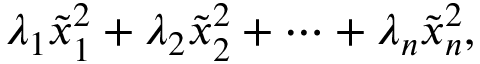Convert formula to latex. <formula><loc_0><loc_0><loc_500><loc_500>\lambda _ { 1 } { \tilde { x } } _ { 1 } ^ { 2 } + \lambda _ { 2 } { \tilde { x } } _ { 2 } ^ { 2 } + \cdots + \lambda _ { n } { \tilde { x } } _ { n } ^ { 2 } ,</formula> 